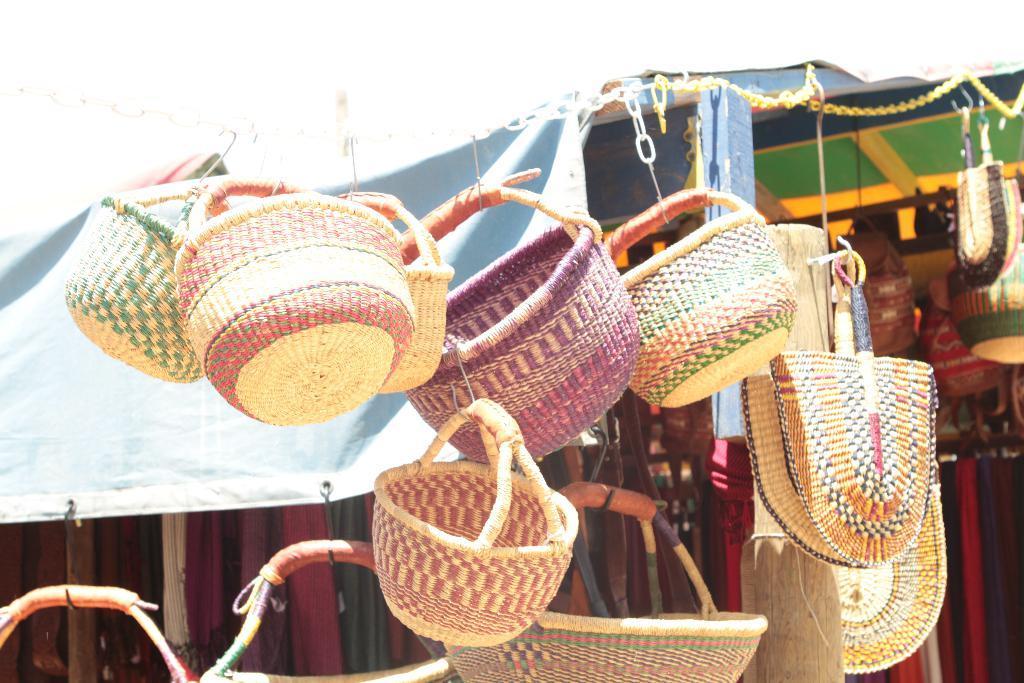In one or two sentences, can you explain what this image depicts? This picture is taken from outside of the city and it is sunny. In this image, in the middle, we can see few baskets which are tied with a thread. In the background, we can see a cloth and few baskets. At the top, we can see white color. 